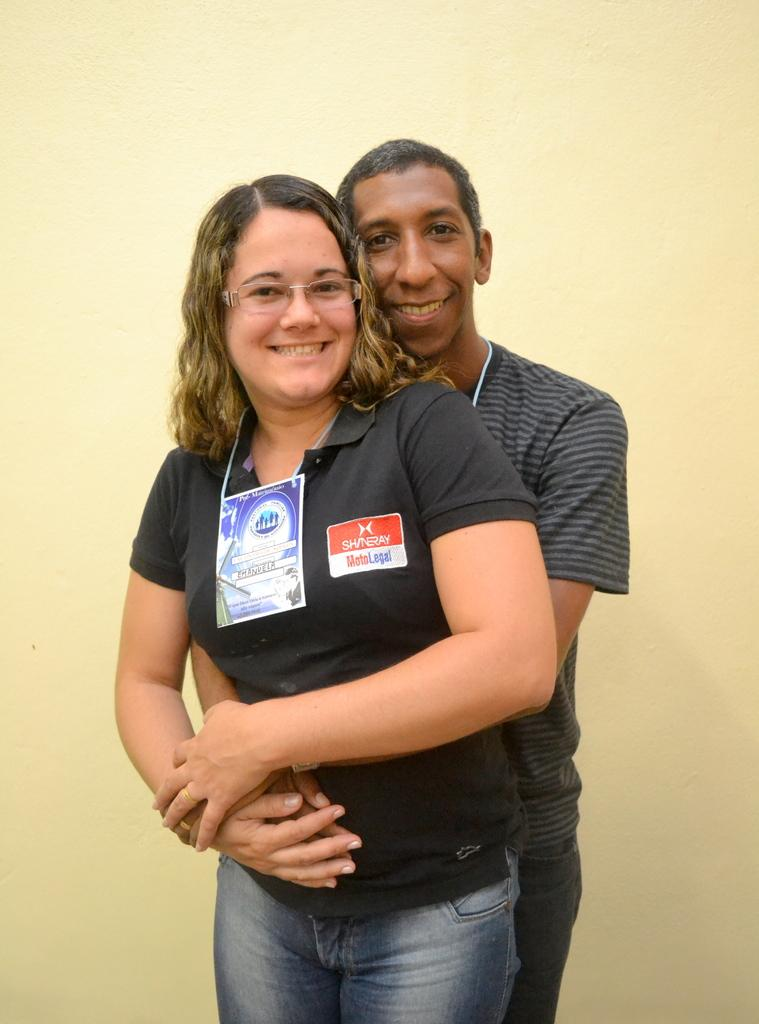How many people are in the image? There are two people in the image, a man and a woman. What are the man and the woman doing in the image? Both the man and the woman are standing. What is the emotional expression of the man and the woman in the image? The man and the woman are smiling. What is the woman wearing that might indicate her identity? The woman is wearing an identity card. What accessory is the woman wearing in the image? The woman is wearing glasses. How many giraffes can be seen in the image? There are no giraffes present in the image. Why is the man crying in the image? The man is not crying in the image; he is smiling. 